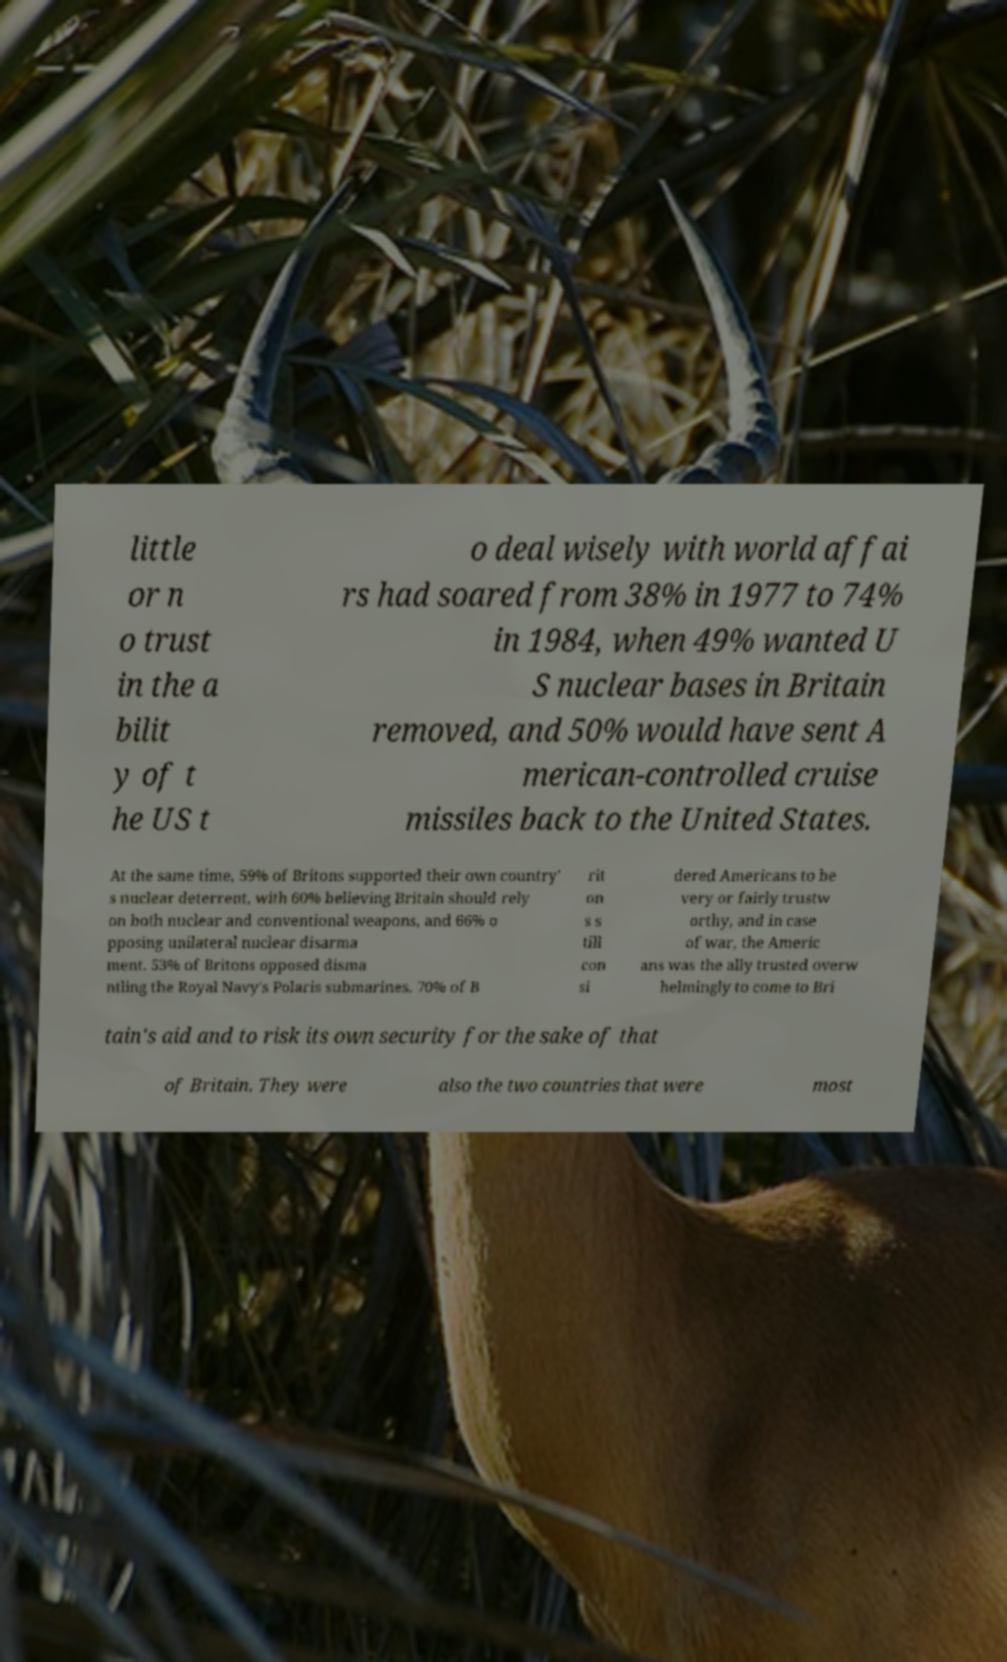There's text embedded in this image that I need extracted. Can you transcribe it verbatim? little or n o trust in the a bilit y of t he US t o deal wisely with world affai rs had soared from 38% in 1977 to 74% in 1984, when 49% wanted U S nuclear bases in Britain removed, and 50% would have sent A merican-controlled cruise missiles back to the United States. At the same time, 59% of Britons supported their own country' s nuclear deterrent, with 60% believing Britain should rely on both nuclear and conventional weapons, and 66% o pposing unilateral nuclear disarma ment. 53% of Britons opposed disma ntling the Royal Navy's Polaris submarines. 70% of B rit on s s till con si dered Americans to be very or fairly trustw orthy, and in case of war, the Americ ans was the ally trusted overw helmingly to come to Bri tain's aid and to risk its own security for the sake of that of Britain. They were also the two countries that were most 